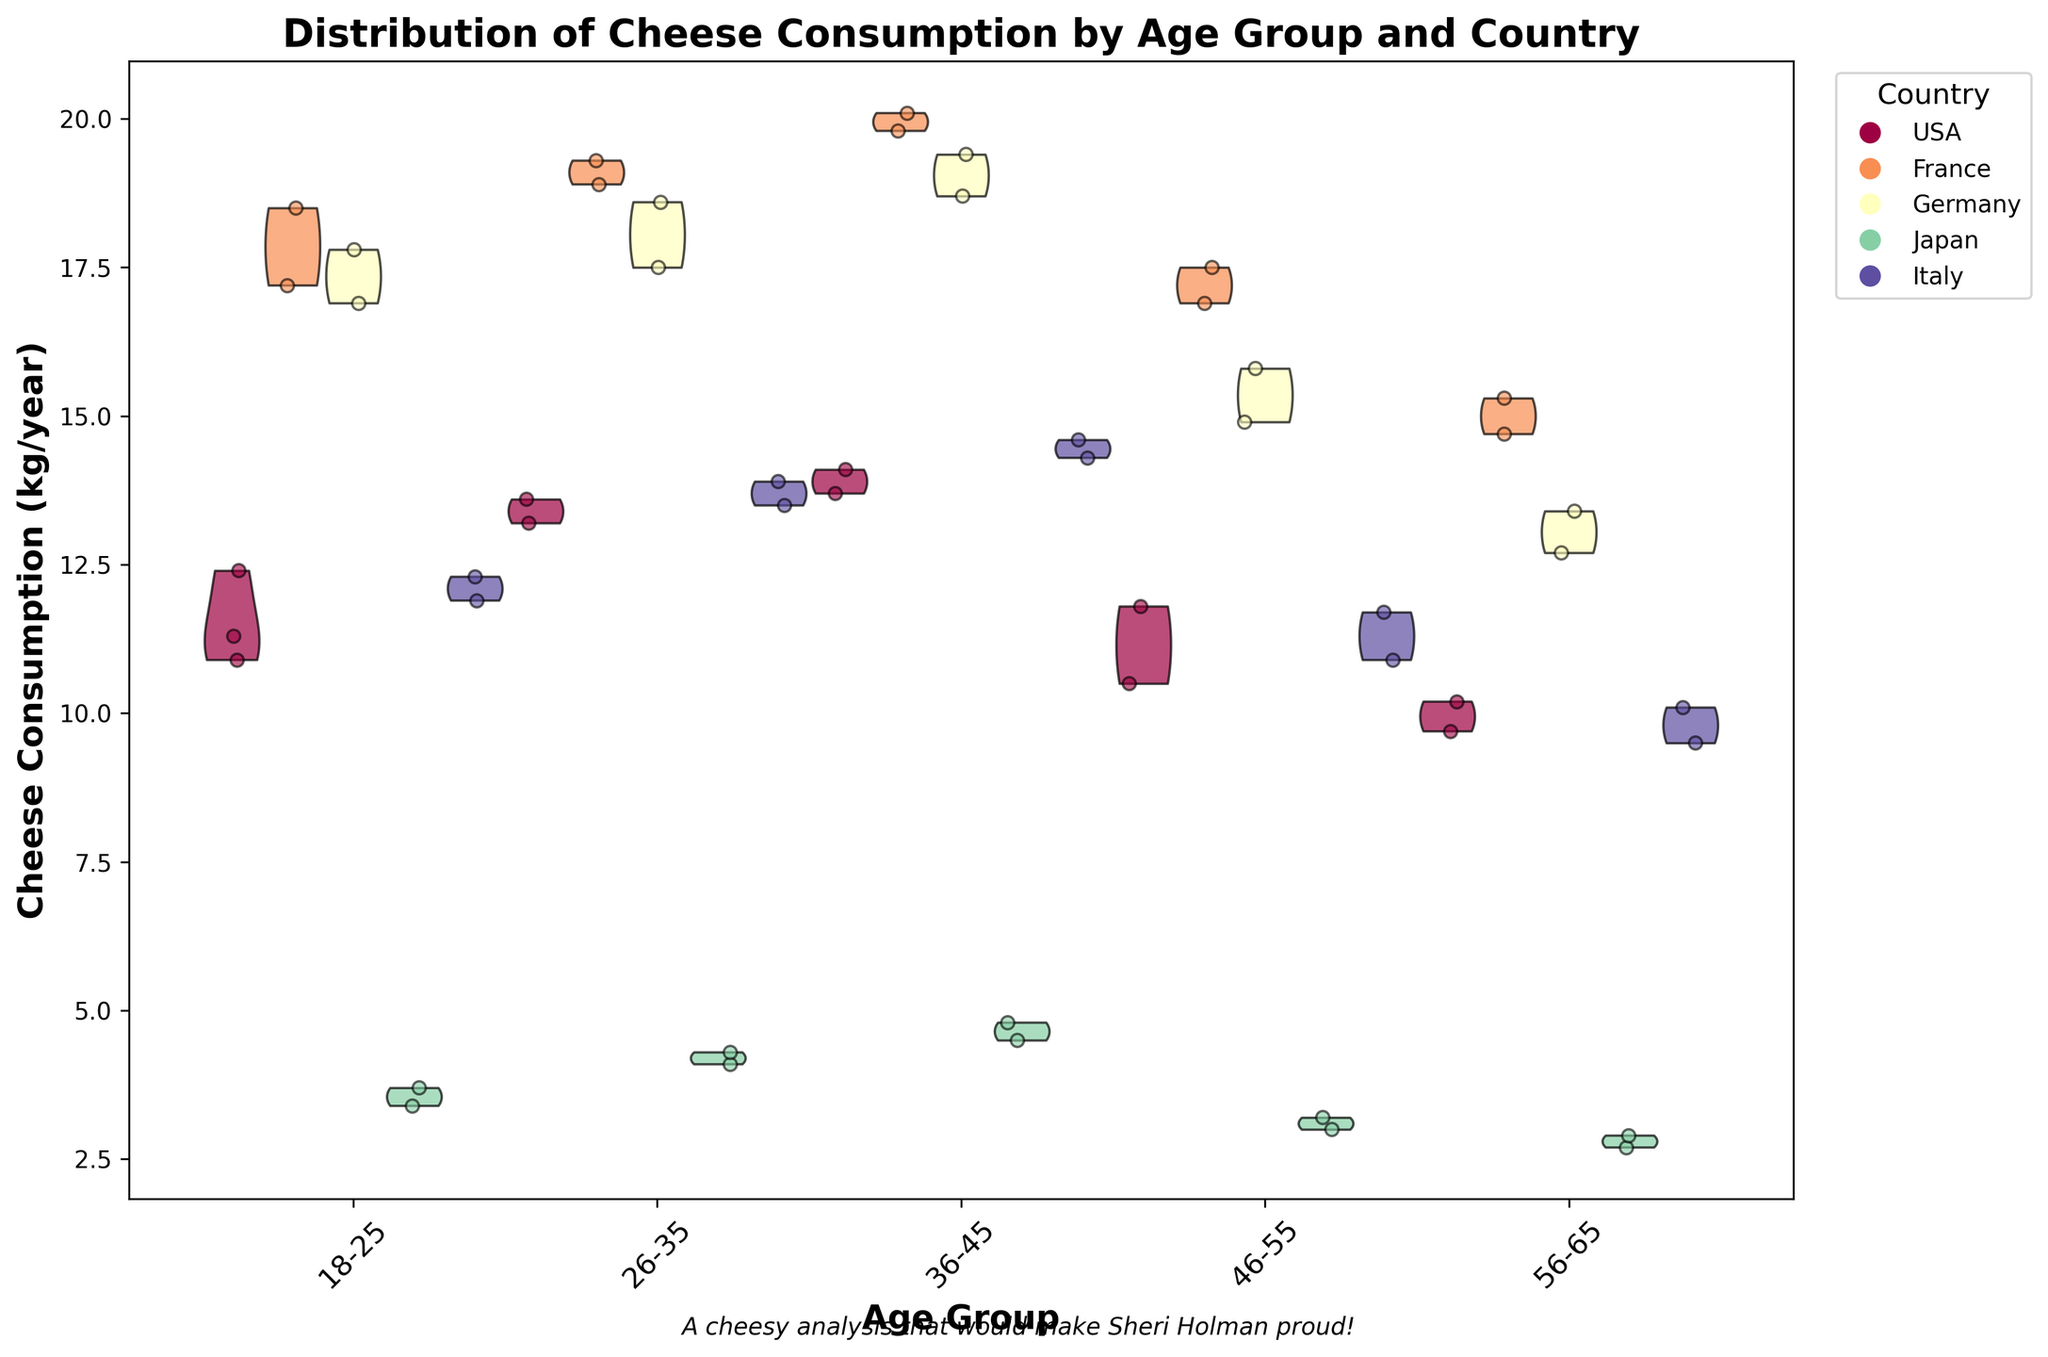What's the title of the figure? The title is usually the text above the chart that summarizes the content. In this case, the title of the figure is clearly written at the top of the chart.
Answer: Distribution of Cheese Consumption by Age Group and Country What are the x-axis labels in the chart? The x-axis labels represent the different age groups. These are horizontally aligned at the bottom of the chart. They are usually readable by tilting the head slightly or rotating the page.
Answer: Age Group Which country has the highest average cheese consumption for the 36-45 age group? By looking at the violins and their central tendency for the 36-45 age group, it is apparent that France has the highest average cheese consumption as its violin plot is centered around a higher value compared to other countries for this age group.
Answer: France Which country has the most varied cheese consumption among the 18-25 age group? Variance can be judged by the width and spread of the violins. The wider the violin, the more varied the data. In the 18-25 age group, France has the widest violin plot, indicating the most varied cheese consumption within this age group.
Answer: France Comparing Japan and Italy, which country has a lower median cheese consumption for the 46-55 age group? To compare, look at the central, thicker part of the violins for the 46-55 age group for both countries. Japan's median consumption is visibly lower than Italy's in this age group.
Answer: Japan What country shows a decreasing trend of cheese consumption with increasing age groups? By examining the positions of the peaks of the violin plots from left to right, Japan shows a decreasing trend as the peaks reduce consistently from the youngest to the oldest age group.
Answer: Japan How does the cheese consumption in Germany's 26-35 age group compare to other categories? By visually comparing the violin plot density, it is evident that Germany's cheese consumption in the 26-35 age group is higher compared to younger or older age groups for Germans but generally moderate compared to other countries' equivalent age groups.
Answer: Germany's 26-35 age group consumption is higher among other German age groups but moderate compared to other countries What is a notable pattern in cheese consumption for Italy? Observing the violin plots, Italy's cheese consumption tends to peak in middle age (36-45) and then decline. This pattern forms a noticeable bell shape when moving across the age groups.
Answer: Peaks in middle age, then declines In the chart, what is depicted by the jittered points within the violins? Jittered points represent individual data points within each age group for every country, providing a sense of density and distribution within the categories. They give specific values and show how spread out the data is within the groups.
Answer: Individual data points within the violins What colors represent the different countries, and why is this important? The colors represent different countries. It is important as it helps in visually distinguishing different countries' data within the same age group, providing clarity and understanding of the distribution and comparison across the countries. The chart legend shows America's (blue), France's (orange), Germany's (green), Japan's (red), and Italy's (purple) vibrant color codes.
Answer: Different colors for different countries, enhancing distinguishability 